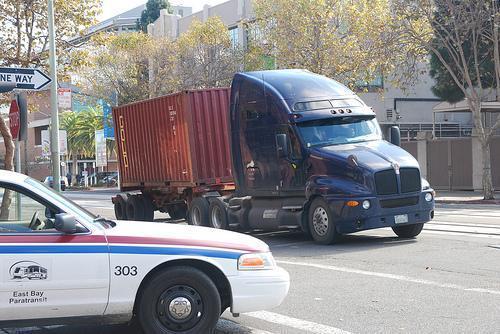How many people are running near the big truck?
Give a very brief answer. 0. 